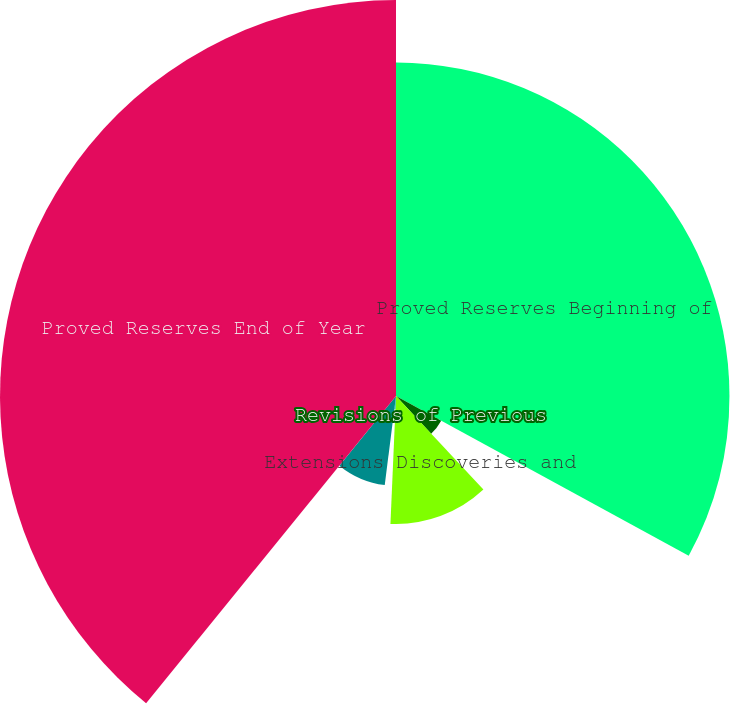<chart> <loc_0><loc_0><loc_500><loc_500><pie_chart><fcel>Proved Reserves Beginning of<fcel>Revisions of Previous<fcel>Extensions Discoveries and<fcel>Sale of Minerals in Place<fcel>Production<fcel>Proved Reserves End of Year<nl><fcel>32.95%<fcel>5.09%<fcel>12.65%<fcel>1.31%<fcel>8.87%<fcel>39.13%<nl></chart> 